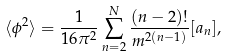Convert formula to latex. <formula><loc_0><loc_0><loc_500><loc_500>\langle \phi ^ { 2 } \rangle = \frac { 1 } { 1 6 \pi ^ { 2 } } \sum _ { n = 2 } ^ { N } \frac { ( n - 2 ) ! } { m ^ { 2 ( n - 1 ) } } [ a _ { n } ] ,</formula> 